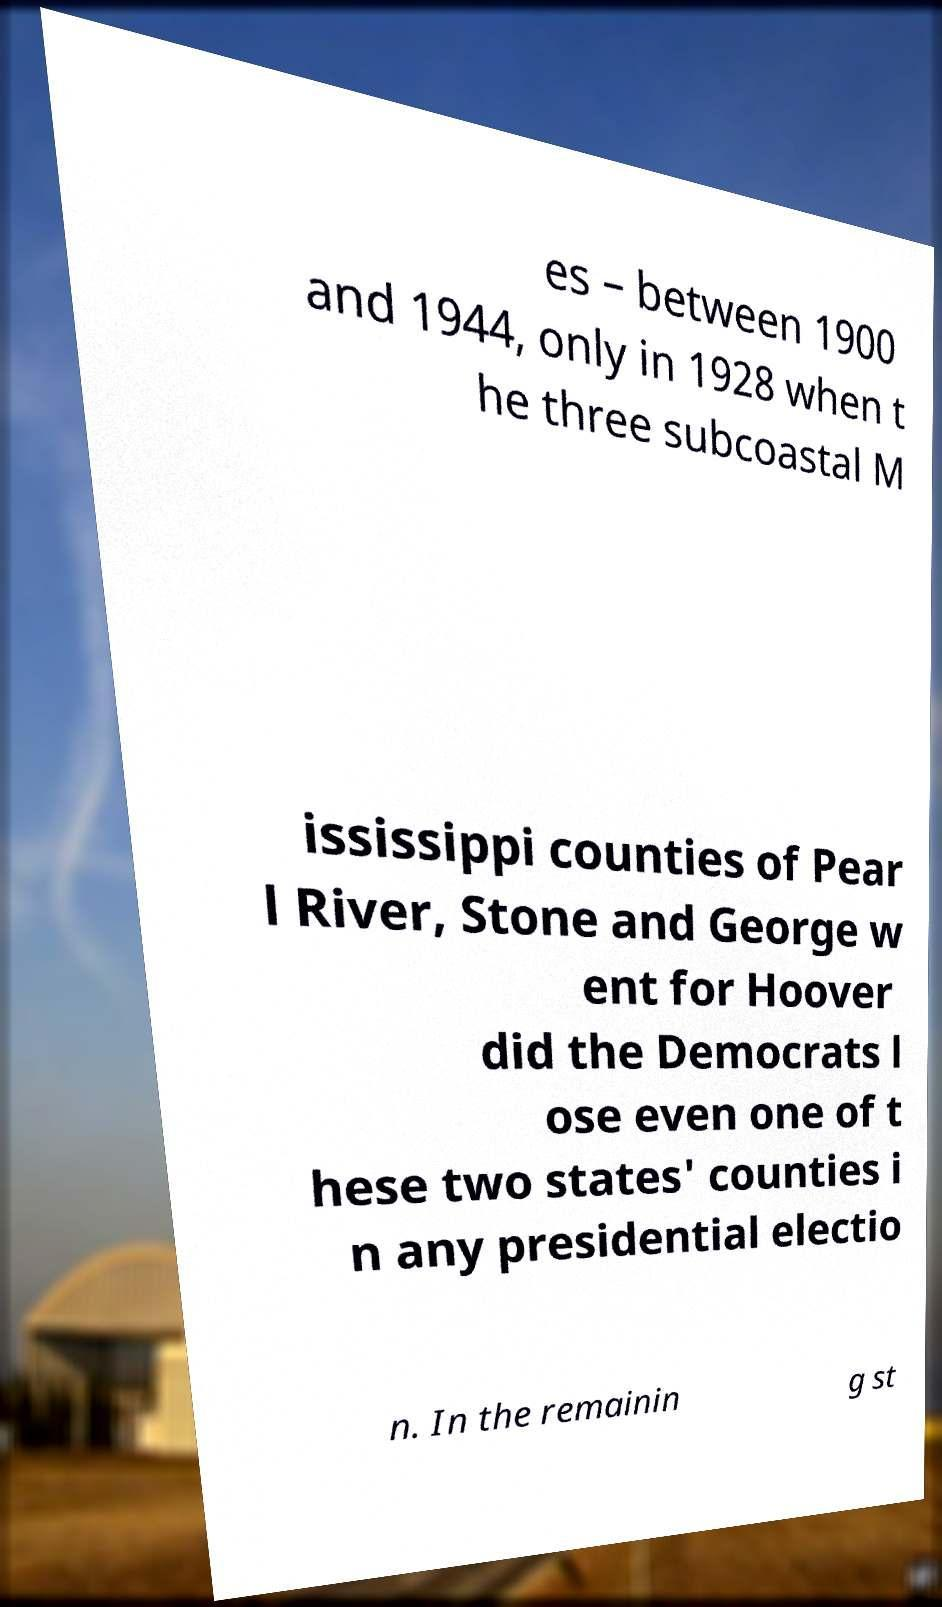What messages or text are displayed in this image? I need them in a readable, typed format. es – between 1900 and 1944, only in 1928 when t he three subcoastal M ississippi counties of Pear l River, Stone and George w ent for Hoover did the Democrats l ose even one of t hese two states' counties i n any presidential electio n. In the remainin g st 